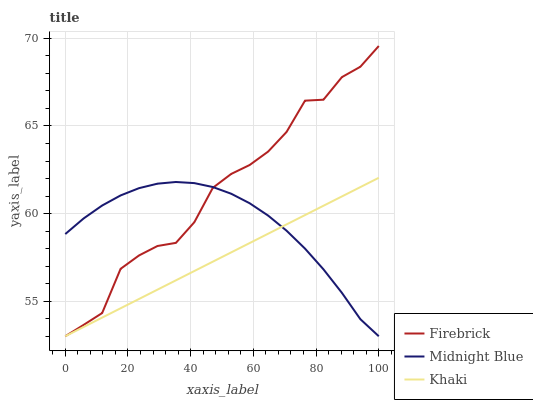Does Midnight Blue have the minimum area under the curve?
Answer yes or no. No. Does Midnight Blue have the maximum area under the curve?
Answer yes or no. No. Is Midnight Blue the smoothest?
Answer yes or no. No. Is Midnight Blue the roughest?
Answer yes or no. No. Does Khaki have the highest value?
Answer yes or no. No. 